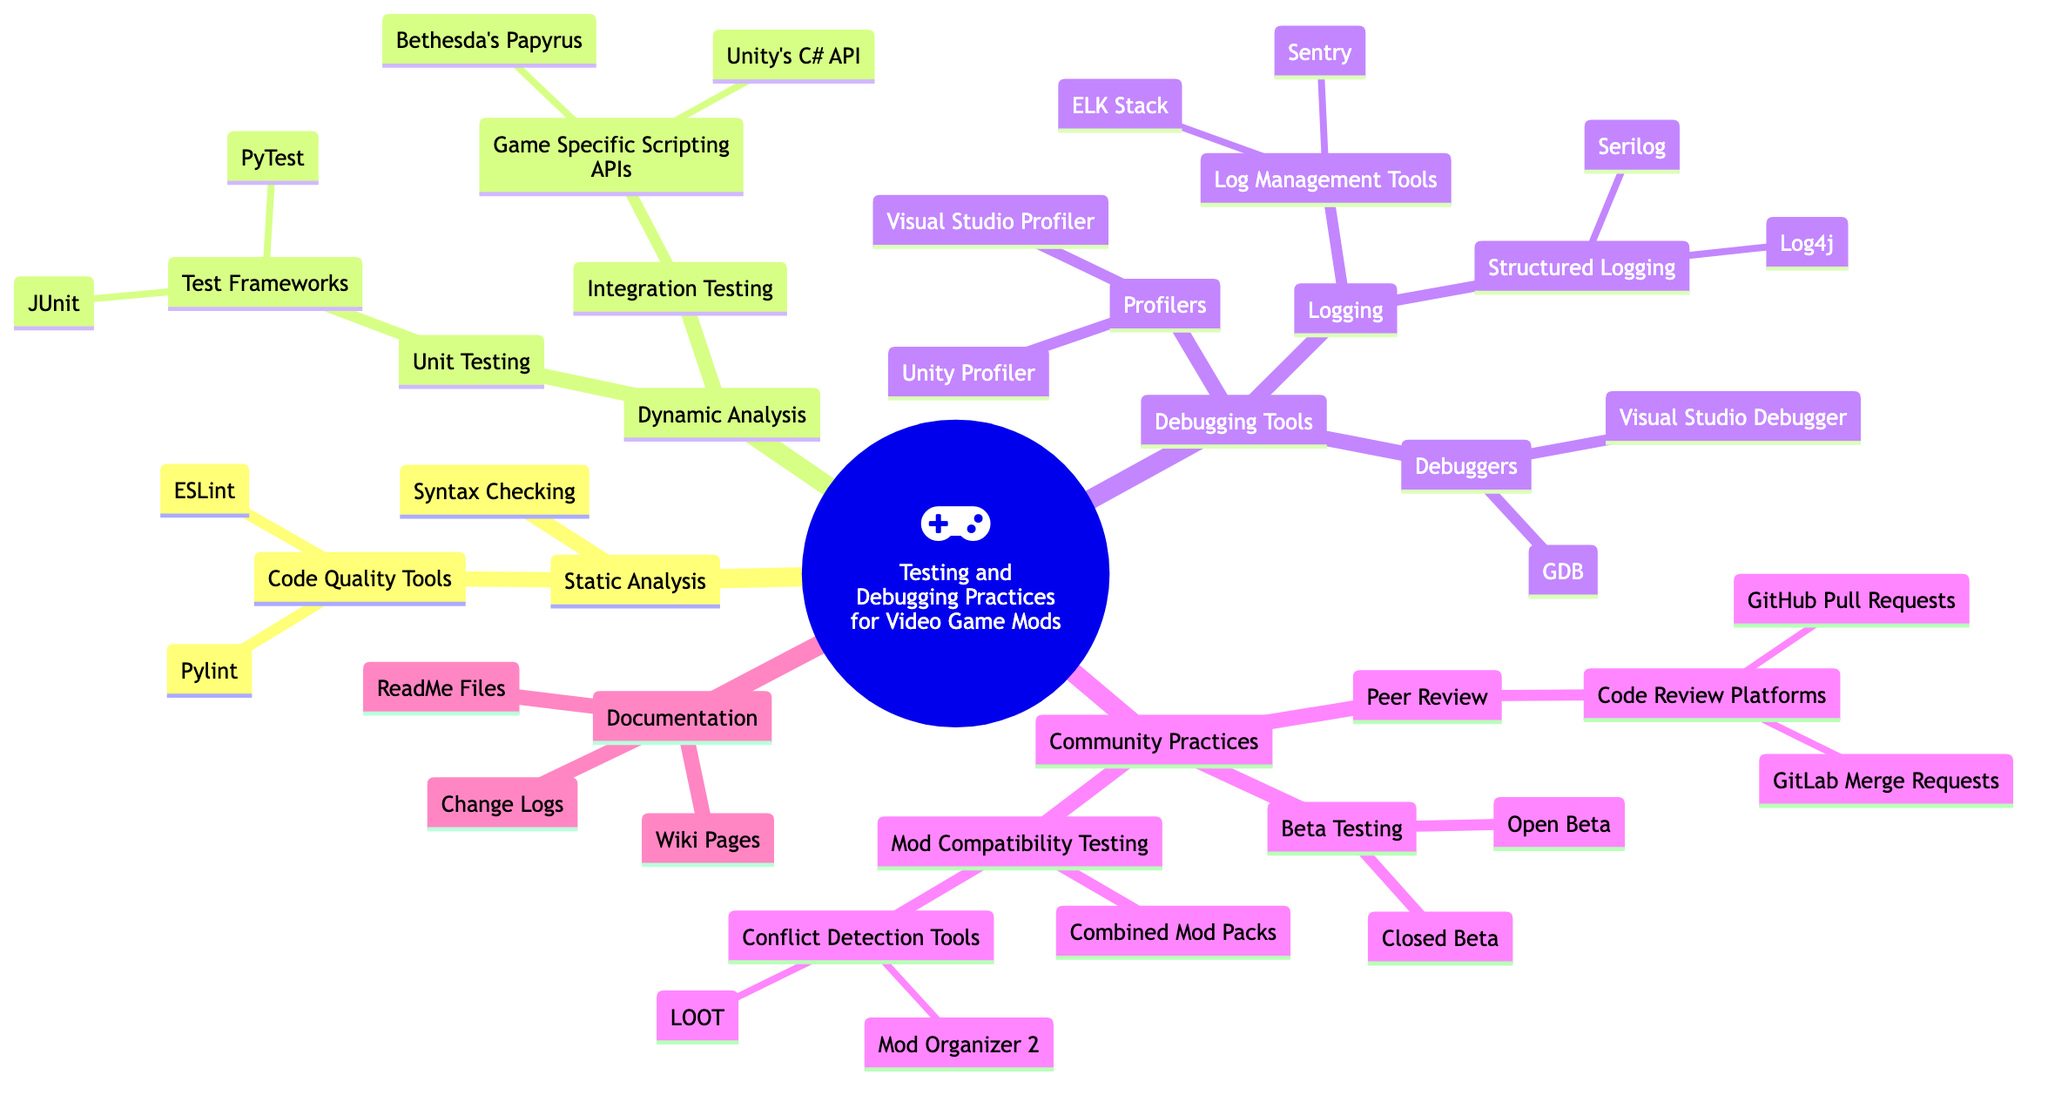What's the top-level concept in this diagram? The highest node in the structure presents the main idea of the diagram, which is "Testing and Debugging Practices for Video Game Mods".
Answer: Testing and Debugging Practices for Video Game Mods How many subcategories are under "Debugging Tools"? "Debugging Tools" directly includes three subcategories: "Profilers", "Debuggers", and "Logging". Therefore, by counting these, the answer is three.
Answer: 3 Which tools are categorized under "Code Quality Tools"? "Code Quality Tools" has two specific tools listed as sub-elements: "Pylint" and "ESLint", which are both important for maintaining code quality in mods.
Answer: Pylint, ESLint What is a practice listed under "Dynamic Analysis"? Under "Dynamic Analysis", there are two listed practices: "Unit Testing" and "Integration Testing". Both are essential for ensuring the functionality of mods.
Answer: Unit Testing What type of testing is related to "Bethesda's Papyrus"? "Bethesda's Papyrus" is mentioned specifically under the "Integration Testing" subcategory, which is focused on game-specific scripting APIs. This indicates that it is a method of testing how well mods integrate with the game's API.
Answer: Integration Testing Which platforms are highlighted for "Code Review"? The code review platforms mentioned under "Peer Review" include "GitHub Pull Requests" and "GitLab Merge Requests", which are popular tools used for collaborative code reviews in mod development.
Answer: GitHub Pull Requests, GitLab Merge Requests How does "Logging" relate to "Debugging Tools"? "Logging" is one of the subcategories beneath "Debugging Tools", showing that it is a crucial part of the debugging process, helping track errors and behaviors within video game mods.
Answer: Debugging Tools What are two practices involved in "Beta Testing"? Under "Beta Testing," two practices are specified: "Closed Beta" and "Open Beta", which refer to different approaches for testing mods with users before public release.
Answer: Closed Beta, Open Beta Which profiling tools are listed in the concept map? The two profiling tools highlighted are "Visual Studio Profiler" and "Unity Profiler", which are used to analyze performance issues in modding.
Answer: Visual Studio Profiler, Unity Profiler 